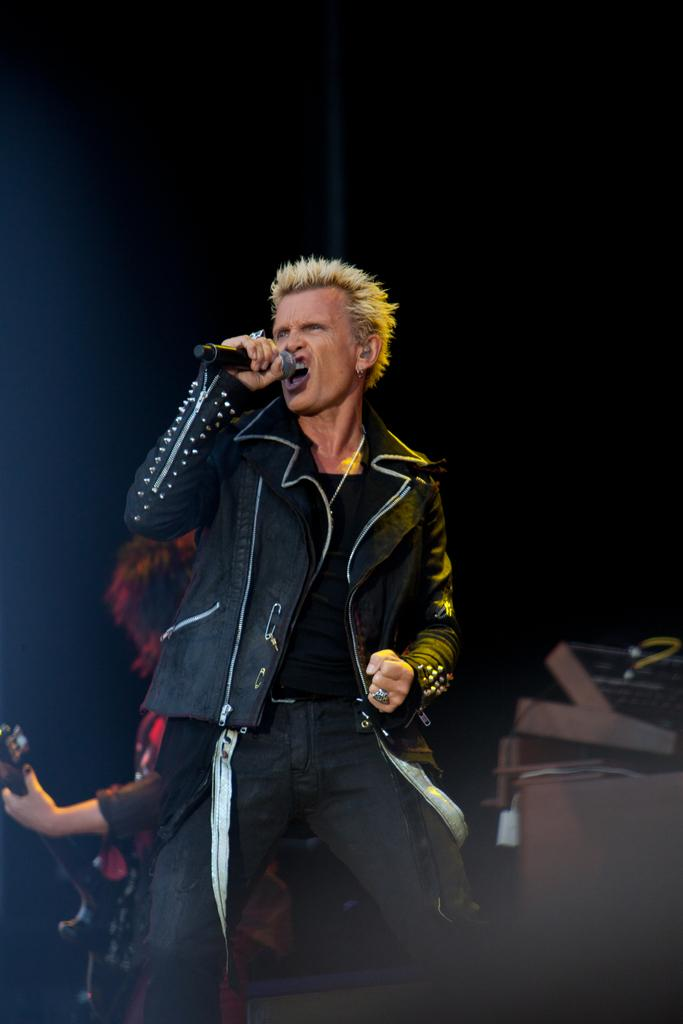What is the person in the image holding? The person is holding a microphone in the image. What else can be seen in the image besides the person with the microphone? There are musical instruments in the image. What type of window can be seen in the image? There is no window present in the image. What role does the governor play in the image? There is no governor present in the image. 